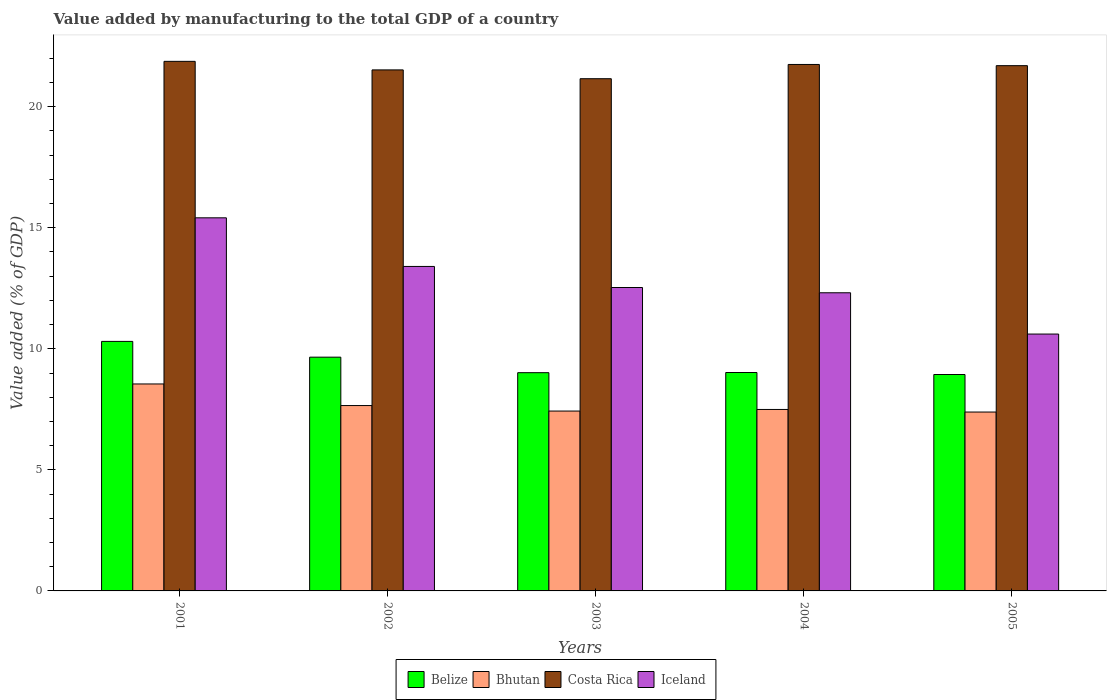How many groups of bars are there?
Make the answer very short. 5. Are the number of bars per tick equal to the number of legend labels?
Keep it short and to the point. Yes. Are the number of bars on each tick of the X-axis equal?
Your response must be concise. Yes. How many bars are there on the 1st tick from the left?
Ensure brevity in your answer.  4. How many bars are there on the 1st tick from the right?
Ensure brevity in your answer.  4. What is the label of the 3rd group of bars from the left?
Provide a short and direct response. 2003. In how many cases, is the number of bars for a given year not equal to the number of legend labels?
Provide a succinct answer. 0. What is the value added by manufacturing to the total GDP in Iceland in 2005?
Offer a terse response. 10.61. Across all years, what is the maximum value added by manufacturing to the total GDP in Bhutan?
Give a very brief answer. 8.55. Across all years, what is the minimum value added by manufacturing to the total GDP in Iceland?
Your answer should be compact. 10.61. In which year was the value added by manufacturing to the total GDP in Costa Rica minimum?
Your response must be concise. 2003. What is the total value added by manufacturing to the total GDP in Bhutan in the graph?
Make the answer very short. 38.52. What is the difference between the value added by manufacturing to the total GDP in Bhutan in 2001 and that in 2003?
Ensure brevity in your answer.  1.12. What is the difference between the value added by manufacturing to the total GDP in Bhutan in 2005 and the value added by manufacturing to the total GDP in Costa Rica in 2004?
Your response must be concise. -14.36. What is the average value added by manufacturing to the total GDP in Bhutan per year?
Offer a terse response. 7.7. In the year 2003, what is the difference between the value added by manufacturing to the total GDP in Costa Rica and value added by manufacturing to the total GDP in Belize?
Provide a short and direct response. 12.14. In how many years, is the value added by manufacturing to the total GDP in Belize greater than 10 %?
Provide a short and direct response. 1. What is the ratio of the value added by manufacturing to the total GDP in Bhutan in 2001 to that in 2005?
Provide a succinct answer. 1.16. Is the value added by manufacturing to the total GDP in Iceland in 2001 less than that in 2003?
Provide a short and direct response. No. Is the difference between the value added by manufacturing to the total GDP in Costa Rica in 2002 and 2003 greater than the difference between the value added by manufacturing to the total GDP in Belize in 2002 and 2003?
Your answer should be compact. No. What is the difference between the highest and the second highest value added by manufacturing to the total GDP in Bhutan?
Give a very brief answer. 0.89. What is the difference between the highest and the lowest value added by manufacturing to the total GDP in Belize?
Make the answer very short. 1.37. Is it the case that in every year, the sum of the value added by manufacturing to the total GDP in Costa Rica and value added by manufacturing to the total GDP in Bhutan is greater than the sum of value added by manufacturing to the total GDP in Iceland and value added by manufacturing to the total GDP in Belize?
Your response must be concise. Yes. What does the 4th bar from the left in 2001 represents?
Give a very brief answer. Iceland. What does the 4th bar from the right in 2005 represents?
Your answer should be compact. Belize. Is it the case that in every year, the sum of the value added by manufacturing to the total GDP in Costa Rica and value added by manufacturing to the total GDP in Belize is greater than the value added by manufacturing to the total GDP in Bhutan?
Your answer should be compact. Yes. How many bars are there?
Give a very brief answer. 20. Does the graph contain grids?
Your response must be concise. No. Where does the legend appear in the graph?
Keep it short and to the point. Bottom center. How are the legend labels stacked?
Give a very brief answer. Horizontal. What is the title of the graph?
Offer a very short reply. Value added by manufacturing to the total GDP of a country. What is the label or title of the X-axis?
Provide a succinct answer. Years. What is the label or title of the Y-axis?
Offer a very short reply. Value added (% of GDP). What is the Value added (% of GDP) in Belize in 2001?
Give a very brief answer. 10.31. What is the Value added (% of GDP) in Bhutan in 2001?
Your answer should be very brief. 8.55. What is the Value added (% of GDP) in Costa Rica in 2001?
Give a very brief answer. 21.87. What is the Value added (% of GDP) of Iceland in 2001?
Your answer should be very brief. 15.41. What is the Value added (% of GDP) in Belize in 2002?
Make the answer very short. 9.66. What is the Value added (% of GDP) in Bhutan in 2002?
Your answer should be very brief. 7.66. What is the Value added (% of GDP) in Costa Rica in 2002?
Ensure brevity in your answer.  21.52. What is the Value added (% of GDP) in Iceland in 2002?
Ensure brevity in your answer.  13.4. What is the Value added (% of GDP) of Belize in 2003?
Give a very brief answer. 9.01. What is the Value added (% of GDP) of Bhutan in 2003?
Give a very brief answer. 7.43. What is the Value added (% of GDP) of Costa Rica in 2003?
Give a very brief answer. 21.16. What is the Value added (% of GDP) in Iceland in 2003?
Your response must be concise. 12.53. What is the Value added (% of GDP) in Belize in 2004?
Ensure brevity in your answer.  9.02. What is the Value added (% of GDP) of Bhutan in 2004?
Offer a very short reply. 7.5. What is the Value added (% of GDP) of Costa Rica in 2004?
Your answer should be very brief. 21.74. What is the Value added (% of GDP) in Iceland in 2004?
Provide a succinct answer. 12.31. What is the Value added (% of GDP) in Belize in 2005?
Your answer should be very brief. 8.94. What is the Value added (% of GDP) in Bhutan in 2005?
Offer a very short reply. 7.39. What is the Value added (% of GDP) in Costa Rica in 2005?
Provide a short and direct response. 21.7. What is the Value added (% of GDP) in Iceland in 2005?
Ensure brevity in your answer.  10.61. Across all years, what is the maximum Value added (% of GDP) of Belize?
Your response must be concise. 10.31. Across all years, what is the maximum Value added (% of GDP) in Bhutan?
Your answer should be very brief. 8.55. Across all years, what is the maximum Value added (% of GDP) in Costa Rica?
Provide a succinct answer. 21.87. Across all years, what is the maximum Value added (% of GDP) in Iceland?
Offer a very short reply. 15.41. Across all years, what is the minimum Value added (% of GDP) in Belize?
Your answer should be compact. 8.94. Across all years, what is the minimum Value added (% of GDP) of Bhutan?
Keep it short and to the point. 7.39. Across all years, what is the minimum Value added (% of GDP) in Costa Rica?
Keep it short and to the point. 21.16. Across all years, what is the minimum Value added (% of GDP) in Iceland?
Offer a very short reply. 10.61. What is the total Value added (% of GDP) of Belize in the graph?
Offer a terse response. 46.94. What is the total Value added (% of GDP) in Bhutan in the graph?
Offer a very short reply. 38.52. What is the total Value added (% of GDP) of Costa Rica in the graph?
Your answer should be compact. 107.99. What is the total Value added (% of GDP) in Iceland in the graph?
Keep it short and to the point. 64.27. What is the difference between the Value added (% of GDP) in Belize in 2001 and that in 2002?
Offer a terse response. 0.65. What is the difference between the Value added (% of GDP) in Bhutan in 2001 and that in 2002?
Keep it short and to the point. 0.89. What is the difference between the Value added (% of GDP) of Costa Rica in 2001 and that in 2002?
Your answer should be very brief. 0.35. What is the difference between the Value added (% of GDP) in Iceland in 2001 and that in 2002?
Keep it short and to the point. 2.01. What is the difference between the Value added (% of GDP) of Belize in 2001 and that in 2003?
Your answer should be compact. 1.29. What is the difference between the Value added (% of GDP) in Bhutan in 2001 and that in 2003?
Give a very brief answer. 1.12. What is the difference between the Value added (% of GDP) of Costa Rica in 2001 and that in 2003?
Your response must be concise. 0.72. What is the difference between the Value added (% of GDP) of Iceland in 2001 and that in 2003?
Give a very brief answer. 2.88. What is the difference between the Value added (% of GDP) in Belize in 2001 and that in 2004?
Your answer should be very brief. 1.28. What is the difference between the Value added (% of GDP) in Bhutan in 2001 and that in 2004?
Offer a very short reply. 1.05. What is the difference between the Value added (% of GDP) in Costa Rica in 2001 and that in 2004?
Offer a very short reply. 0.13. What is the difference between the Value added (% of GDP) of Iceland in 2001 and that in 2004?
Your answer should be compact. 3.1. What is the difference between the Value added (% of GDP) in Belize in 2001 and that in 2005?
Your answer should be compact. 1.37. What is the difference between the Value added (% of GDP) in Bhutan in 2001 and that in 2005?
Ensure brevity in your answer.  1.16. What is the difference between the Value added (% of GDP) of Costa Rica in 2001 and that in 2005?
Your response must be concise. 0.18. What is the difference between the Value added (% of GDP) of Iceland in 2001 and that in 2005?
Your response must be concise. 4.8. What is the difference between the Value added (% of GDP) in Belize in 2002 and that in 2003?
Offer a terse response. 0.64. What is the difference between the Value added (% of GDP) of Bhutan in 2002 and that in 2003?
Provide a succinct answer. 0.23. What is the difference between the Value added (% of GDP) of Costa Rica in 2002 and that in 2003?
Your answer should be very brief. 0.36. What is the difference between the Value added (% of GDP) of Iceland in 2002 and that in 2003?
Offer a terse response. 0.87. What is the difference between the Value added (% of GDP) in Belize in 2002 and that in 2004?
Give a very brief answer. 0.63. What is the difference between the Value added (% of GDP) in Bhutan in 2002 and that in 2004?
Provide a short and direct response. 0.16. What is the difference between the Value added (% of GDP) in Costa Rica in 2002 and that in 2004?
Provide a short and direct response. -0.22. What is the difference between the Value added (% of GDP) of Iceland in 2002 and that in 2004?
Offer a terse response. 1.09. What is the difference between the Value added (% of GDP) of Belize in 2002 and that in 2005?
Ensure brevity in your answer.  0.72. What is the difference between the Value added (% of GDP) in Bhutan in 2002 and that in 2005?
Provide a short and direct response. 0.27. What is the difference between the Value added (% of GDP) of Costa Rica in 2002 and that in 2005?
Your answer should be very brief. -0.17. What is the difference between the Value added (% of GDP) in Iceland in 2002 and that in 2005?
Make the answer very short. 2.79. What is the difference between the Value added (% of GDP) of Belize in 2003 and that in 2004?
Make the answer very short. -0.01. What is the difference between the Value added (% of GDP) of Bhutan in 2003 and that in 2004?
Your answer should be very brief. -0.07. What is the difference between the Value added (% of GDP) of Costa Rica in 2003 and that in 2004?
Ensure brevity in your answer.  -0.59. What is the difference between the Value added (% of GDP) of Iceland in 2003 and that in 2004?
Your response must be concise. 0.22. What is the difference between the Value added (% of GDP) of Belize in 2003 and that in 2005?
Your response must be concise. 0.08. What is the difference between the Value added (% of GDP) in Bhutan in 2003 and that in 2005?
Offer a very short reply. 0.04. What is the difference between the Value added (% of GDP) of Costa Rica in 2003 and that in 2005?
Offer a very short reply. -0.54. What is the difference between the Value added (% of GDP) in Iceland in 2003 and that in 2005?
Your answer should be very brief. 1.92. What is the difference between the Value added (% of GDP) in Belize in 2004 and that in 2005?
Provide a short and direct response. 0.08. What is the difference between the Value added (% of GDP) in Bhutan in 2004 and that in 2005?
Ensure brevity in your answer.  0.11. What is the difference between the Value added (% of GDP) of Costa Rica in 2004 and that in 2005?
Keep it short and to the point. 0.05. What is the difference between the Value added (% of GDP) of Iceland in 2004 and that in 2005?
Ensure brevity in your answer.  1.71. What is the difference between the Value added (% of GDP) of Belize in 2001 and the Value added (% of GDP) of Bhutan in 2002?
Your answer should be compact. 2.65. What is the difference between the Value added (% of GDP) of Belize in 2001 and the Value added (% of GDP) of Costa Rica in 2002?
Your answer should be compact. -11.21. What is the difference between the Value added (% of GDP) in Belize in 2001 and the Value added (% of GDP) in Iceland in 2002?
Make the answer very short. -3.1. What is the difference between the Value added (% of GDP) in Bhutan in 2001 and the Value added (% of GDP) in Costa Rica in 2002?
Your answer should be very brief. -12.97. What is the difference between the Value added (% of GDP) of Bhutan in 2001 and the Value added (% of GDP) of Iceland in 2002?
Provide a short and direct response. -4.85. What is the difference between the Value added (% of GDP) of Costa Rica in 2001 and the Value added (% of GDP) of Iceland in 2002?
Provide a short and direct response. 8.47. What is the difference between the Value added (% of GDP) of Belize in 2001 and the Value added (% of GDP) of Bhutan in 2003?
Your response must be concise. 2.88. What is the difference between the Value added (% of GDP) in Belize in 2001 and the Value added (% of GDP) in Costa Rica in 2003?
Provide a succinct answer. -10.85. What is the difference between the Value added (% of GDP) of Belize in 2001 and the Value added (% of GDP) of Iceland in 2003?
Provide a succinct answer. -2.23. What is the difference between the Value added (% of GDP) of Bhutan in 2001 and the Value added (% of GDP) of Costa Rica in 2003?
Make the answer very short. -12.61. What is the difference between the Value added (% of GDP) in Bhutan in 2001 and the Value added (% of GDP) in Iceland in 2003?
Your answer should be very brief. -3.98. What is the difference between the Value added (% of GDP) in Costa Rica in 2001 and the Value added (% of GDP) in Iceland in 2003?
Your answer should be compact. 9.34. What is the difference between the Value added (% of GDP) of Belize in 2001 and the Value added (% of GDP) of Bhutan in 2004?
Make the answer very short. 2.81. What is the difference between the Value added (% of GDP) of Belize in 2001 and the Value added (% of GDP) of Costa Rica in 2004?
Your answer should be very brief. -11.44. What is the difference between the Value added (% of GDP) in Belize in 2001 and the Value added (% of GDP) in Iceland in 2004?
Offer a terse response. -2.01. What is the difference between the Value added (% of GDP) in Bhutan in 2001 and the Value added (% of GDP) in Costa Rica in 2004?
Provide a succinct answer. -13.2. What is the difference between the Value added (% of GDP) of Bhutan in 2001 and the Value added (% of GDP) of Iceland in 2004?
Your response must be concise. -3.77. What is the difference between the Value added (% of GDP) in Costa Rica in 2001 and the Value added (% of GDP) in Iceland in 2004?
Offer a terse response. 9.56. What is the difference between the Value added (% of GDP) of Belize in 2001 and the Value added (% of GDP) of Bhutan in 2005?
Offer a terse response. 2.92. What is the difference between the Value added (% of GDP) of Belize in 2001 and the Value added (% of GDP) of Costa Rica in 2005?
Ensure brevity in your answer.  -11.39. What is the difference between the Value added (% of GDP) of Belize in 2001 and the Value added (% of GDP) of Iceland in 2005?
Ensure brevity in your answer.  -0.3. What is the difference between the Value added (% of GDP) of Bhutan in 2001 and the Value added (% of GDP) of Costa Rica in 2005?
Provide a succinct answer. -13.15. What is the difference between the Value added (% of GDP) of Bhutan in 2001 and the Value added (% of GDP) of Iceland in 2005?
Your answer should be very brief. -2.06. What is the difference between the Value added (% of GDP) in Costa Rica in 2001 and the Value added (% of GDP) in Iceland in 2005?
Keep it short and to the point. 11.26. What is the difference between the Value added (% of GDP) of Belize in 2002 and the Value added (% of GDP) of Bhutan in 2003?
Your answer should be very brief. 2.23. What is the difference between the Value added (% of GDP) in Belize in 2002 and the Value added (% of GDP) in Costa Rica in 2003?
Provide a short and direct response. -11.5. What is the difference between the Value added (% of GDP) of Belize in 2002 and the Value added (% of GDP) of Iceland in 2003?
Offer a very short reply. -2.88. What is the difference between the Value added (% of GDP) in Bhutan in 2002 and the Value added (% of GDP) in Costa Rica in 2003?
Your response must be concise. -13.5. What is the difference between the Value added (% of GDP) in Bhutan in 2002 and the Value added (% of GDP) in Iceland in 2003?
Ensure brevity in your answer.  -4.88. What is the difference between the Value added (% of GDP) of Costa Rica in 2002 and the Value added (% of GDP) of Iceland in 2003?
Provide a succinct answer. 8.99. What is the difference between the Value added (% of GDP) in Belize in 2002 and the Value added (% of GDP) in Bhutan in 2004?
Ensure brevity in your answer.  2.16. What is the difference between the Value added (% of GDP) in Belize in 2002 and the Value added (% of GDP) in Costa Rica in 2004?
Your answer should be very brief. -12.09. What is the difference between the Value added (% of GDP) in Belize in 2002 and the Value added (% of GDP) in Iceland in 2004?
Give a very brief answer. -2.66. What is the difference between the Value added (% of GDP) of Bhutan in 2002 and the Value added (% of GDP) of Costa Rica in 2004?
Your answer should be compact. -14.09. What is the difference between the Value added (% of GDP) of Bhutan in 2002 and the Value added (% of GDP) of Iceland in 2004?
Offer a terse response. -4.66. What is the difference between the Value added (% of GDP) of Costa Rica in 2002 and the Value added (% of GDP) of Iceland in 2004?
Ensure brevity in your answer.  9.21. What is the difference between the Value added (% of GDP) of Belize in 2002 and the Value added (% of GDP) of Bhutan in 2005?
Provide a succinct answer. 2.27. What is the difference between the Value added (% of GDP) of Belize in 2002 and the Value added (% of GDP) of Costa Rica in 2005?
Keep it short and to the point. -12.04. What is the difference between the Value added (% of GDP) in Belize in 2002 and the Value added (% of GDP) in Iceland in 2005?
Give a very brief answer. -0.95. What is the difference between the Value added (% of GDP) of Bhutan in 2002 and the Value added (% of GDP) of Costa Rica in 2005?
Offer a very short reply. -14.04. What is the difference between the Value added (% of GDP) in Bhutan in 2002 and the Value added (% of GDP) in Iceland in 2005?
Provide a short and direct response. -2.95. What is the difference between the Value added (% of GDP) of Costa Rica in 2002 and the Value added (% of GDP) of Iceland in 2005?
Your answer should be very brief. 10.91. What is the difference between the Value added (% of GDP) in Belize in 2003 and the Value added (% of GDP) in Bhutan in 2004?
Your answer should be very brief. 1.52. What is the difference between the Value added (% of GDP) of Belize in 2003 and the Value added (% of GDP) of Costa Rica in 2004?
Your response must be concise. -12.73. What is the difference between the Value added (% of GDP) of Belize in 2003 and the Value added (% of GDP) of Iceland in 2004?
Make the answer very short. -3.3. What is the difference between the Value added (% of GDP) of Bhutan in 2003 and the Value added (% of GDP) of Costa Rica in 2004?
Offer a very short reply. -14.32. What is the difference between the Value added (% of GDP) in Bhutan in 2003 and the Value added (% of GDP) in Iceland in 2004?
Make the answer very short. -4.89. What is the difference between the Value added (% of GDP) of Costa Rica in 2003 and the Value added (% of GDP) of Iceland in 2004?
Give a very brief answer. 8.84. What is the difference between the Value added (% of GDP) of Belize in 2003 and the Value added (% of GDP) of Bhutan in 2005?
Ensure brevity in your answer.  1.63. What is the difference between the Value added (% of GDP) in Belize in 2003 and the Value added (% of GDP) in Costa Rica in 2005?
Your answer should be compact. -12.68. What is the difference between the Value added (% of GDP) in Belize in 2003 and the Value added (% of GDP) in Iceland in 2005?
Provide a succinct answer. -1.6. What is the difference between the Value added (% of GDP) in Bhutan in 2003 and the Value added (% of GDP) in Costa Rica in 2005?
Offer a terse response. -14.27. What is the difference between the Value added (% of GDP) of Bhutan in 2003 and the Value added (% of GDP) of Iceland in 2005?
Offer a terse response. -3.18. What is the difference between the Value added (% of GDP) of Costa Rica in 2003 and the Value added (% of GDP) of Iceland in 2005?
Ensure brevity in your answer.  10.55. What is the difference between the Value added (% of GDP) of Belize in 2004 and the Value added (% of GDP) of Bhutan in 2005?
Give a very brief answer. 1.63. What is the difference between the Value added (% of GDP) of Belize in 2004 and the Value added (% of GDP) of Costa Rica in 2005?
Make the answer very short. -12.67. What is the difference between the Value added (% of GDP) in Belize in 2004 and the Value added (% of GDP) in Iceland in 2005?
Give a very brief answer. -1.59. What is the difference between the Value added (% of GDP) of Bhutan in 2004 and the Value added (% of GDP) of Costa Rica in 2005?
Give a very brief answer. -14.2. What is the difference between the Value added (% of GDP) in Bhutan in 2004 and the Value added (% of GDP) in Iceland in 2005?
Make the answer very short. -3.11. What is the difference between the Value added (% of GDP) in Costa Rica in 2004 and the Value added (% of GDP) in Iceland in 2005?
Your answer should be very brief. 11.14. What is the average Value added (% of GDP) of Belize per year?
Your answer should be compact. 9.39. What is the average Value added (% of GDP) of Bhutan per year?
Provide a succinct answer. 7.7. What is the average Value added (% of GDP) in Costa Rica per year?
Your response must be concise. 21.6. What is the average Value added (% of GDP) of Iceland per year?
Give a very brief answer. 12.85. In the year 2001, what is the difference between the Value added (% of GDP) in Belize and Value added (% of GDP) in Bhutan?
Your response must be concise. 1.76. In the year 2001, what is the difference between the Value added (% of GDP) of Belize and Value added (% of GDP) of Costa Rica?
Make the answer very short. -11.57. In the year 2001, what is the difference between the Value added (% of GDP) of Belize and Value added (% of GDP) of Iceland?
Give a very brief answer. -5.1. In the year 2001, what is the difference between the Value added (% of GDP) in Bhutan and Value added (% of GDP) in Costa Rica?
Keep it short and to the point. -13.33. In the year 2001, what is the difference between the Value added (% of GDP) of Bhutan and Value added (% of GDP) of Iceland?
Offer a very short reply. -6.86. In the year 2001, what is the difference between the Value added (% of GDP) in Costa Rica and Value added (% of GDP) in Iceland?
Make the answer very short. 6.46. In the year 2002, what is the difference between the Value added (% of GDP) of Belize and Value added (% of GDP) of Bhutan?
Provide a short and direct response. 2. In the year 2002, what is the difference between the Value added (% of GDP) of Belize and Value added (% of GDP) of Costa Rica?
Give a very brief answer. -11.87. In the year 2002, what is the difference between the Value added (% of GDP) of Belize and Value added (% of GDP) of Iceland?
Provide a short and direct response. -3.75. In the year 2002, what is the difference between the Value added (% of GDP) in Bhutan and Value added (% of GDP) in Costa Rica?
Offer a terse response. -13.86. In the year 2002, what is the difference between the Value added (% of GDP) of Bhutan and Value added (% of GDP) of Iceland?
Your response must be concise. -5.75. In the year 2002, what is the difference between the Value added (% of GDP) in Costa Rica and Value added (% of GDP) in Iceland?
Your response must be concise. 8.12. In the year 2003, what is the difference between the Value added (% of GDP) in Belize and Value added (% of GDP) in Bhutan?
Ensure brevity in your answer.  1.58. In the year 2003, what is the difference between the Value added (% of GDP) in Belize and Value added (% of GDP) in Costa Rica?
Your answer should be very brief. -12.14. In the year 2003, what is the difference between the Value added (% of GDP) in Belize and Value added (% of GDP) in Iceland?
Make the answer very short. -3.52. In the year 2003, what is the difference between the Value added (% of GDP) in Bhutan and Value added (% of GDP) in Costa Rica?
Make the answer very short. -13.73. In the year 2003, what is the difference between the Value added (% of GDP) of Bhutan and Value added (% of GDP) of Iceland?
Keep it short and to the point. -5.1. In the year 2003, what is the difference between the Value added (% of GDP) in Costa Rica and Value added (% of GDP) in Iceland?
Your answer should be very brief. 8.62. In the year 2004, what is the difference between the Value added (% of GDP) in Belize and Value added (% of GDP) in Bhutan?
Offer a terse response. 1.53. In the year 2004, what is the difference between the Value added (% of GDP) in Belize and Value added (% of GDP) in Costa Rica?
Provide a succinct answer. -12.72. In the year 2004, what is the difference between the Value added (% of GDP) of Belize and Value added (% of GDP) of Iceland?
Offer a very short reply. -3.29. In the year 2004, what is the difference between the Value added (% of GDP) in Bhutan and Value added (% of GDP) in Costa Rica?
Your answer should be very brief. -14.25. In the year 2004, what is the difference between the Value added (% of GDP) in Bhutan and Value added (% of GDP) in Iceland?
Offer a terse response. -4.82. In the year 2004, what is the difference between the Value added (% of GDP) of Costa Rica and Value added (% of GDP) of Iceland?
Provide a succinct answer. 9.43. In the year 2005, what is the difference between the Value added (% of GDP) of Belize and Value added (% of GDP) of Bhutan?
Provide a succinct answer. 1.55. In the year 2005, what is the difference between the Value added (% of GDP) of Belize and Value added (% of GDP) of Costa Rica?
Give a very brief answer. -12.76. In the year 2005, what is the difference between the Value added (% of GDP) in Belize and Value added (% of GDP) in Iceland?
Give a very brief answer. -1.67. In the year 2005, what is the difference between the Value added (% of GDP) of Bhutan and Value added (% of GDP) of Costa Rica?
Ensure brevity in your answer.  -14.31. In the year 2005, what is the difference between the Value added (% of GDP) in Bhutan and Value added (% of GDP) in Iceland?
Ensure brevity in your answer.  -3.22. In the year 2005, what is the difference between the Value added (% of GDP) of Costa Rica and Value added (% of GDP) of Iceland?
Your answer should be compact. 11.09. What is the ratio of the Value added (% of GDP) in Belize in 2001 to that in 2002?
Offer a terse response. 1.07. What is the ratio of the Value added (% of GDP) of Bhutan in 2001 to that in 2002?
Your response must be concise. 1.12. What is the ratio of the Value added (% of GDP) in Costa Rica in 2001 to that in 2002?
Give a very brief answer. 1.02. What is the ratio of the Value added (% of GDP) in Iceland in 2001 to that in 2002?
Offer a terse response. 1.15. What is the ratio of the Value added (% of GDP) of Belize in 2001 to that in 2003?
Provide a short and direct response. 1.14. What is the ratio of the Value added (% of GDP) of Bhutan in 2001 to that in 2003?
Ensure brevity in your answer.  1.15. What is the ratio of the Value added (% of GDP) of Costa Rica in 2001 to that in 2003?
Make the answer very short. 1.03. What is the ratio of the Value added (% of GDP) in Iceland in 2001 to that in 2003?
Your answer should be compact. 1.23. What is the ratio of the Value added (% of GDP) of Belize in 2001 to that in 2004?
Your response must be concise. 1.14. What is the ratio of the Value added (% of GDP) in Bhutan in 2001 to that in 2004?
Your answer should be compact. 1.14. What is the ratio of the Value added (% of GDP) in Costa Rica in 2001 to that in 2004?
Provide a succinct answer. 1.01. What is the ratio of the Value added (% of GDP) in Iceland in 2001 to that in 2004?
Your response must be concise. 1.25. What is the ratio of the Value added (% of GDP) in Belize in 2001 to that in 2005?
Offer a very short reply. 1.15. What is the ratio of the Value added (% of GDP) in Bhutan in 2001 to that in 2005?
Provide a short and direct response. 1.16. What is the ratio of the Value added (% of GDP) of Costa Rica in 2001 to that in 2005?
Your answer should be compact. 1.01. What is the ratio of the Value added (% of GDP) in Iceland in 2001 to that in 2005?
Offer a terse response. 1.45. What is the ratio of the Value added (% of GDP) of Belize in 2002 to that in 2003?
Provide a short and direct response. 1.07. What is the ratio of the Value added (% of GDP) in Bhutan in 2002 to that in 2003?
Offer a terse response. 1.03. What is the ratio of the Value added (% of GDP) of Costa Rica in 2002 to that in 2003?
Your answer should be compact. 1.02. What is the ratio of the Value added (% of GDP) in Iceland in 2002 to that in 2003?
Keep it short and to the point. 1.07. What is the ratio of the Value added (% of GDP) of Belize in 2002 to that in 2004?
Ensure brevity in your answer.  1.07. What is the ratio of the Value added (% of GDP) in Bhutan in 2002 to that in 2004?
Provide a succinct answer. 1.02. What is the ratio of the Value added (% of GDP) of Iceland in 2002 to that in 2004?
Ensure brevity in your answer.  1.09. What is the ratio of the Value added (% of GDP) of Belize in 2002 to that in 2005?
Your response must be concise. 1.08. What is the ratio of the Value added (% of GDP) of Bhutan in 2002 to that in 2005?
Ensure brevity in your answer.  1.04. What is the ratio of the Value added (% of GDP) in Iceland in 2002 to that in 2005?
Provide a succinct answer. 1.26. What is the ratio of the Value added (% of GDP) of Costa Rica in 2003 to that in 2004?
Keep it short and to the point. 0.97. What is the ratio of the Value added (% of GDP) of Iceland in 2003 to that in 2004?
Provide a short and direct response. 1.02. What is the ratio of the Value added (% of GDP) of Belize in 2003 to that in 2005?
Give a very brief answer. 1.01. What is the ratio of the Value added (% of GDP) of Costa Rica in 2003 to that in 2005?
Provide a succinct answer. 0.98. What is the ratio of the Value added (% of GDP) of Iceland in 2003 to that in 2005?
Provide a succinct answer. 1.18. What is the ratio of the Value added (% of GDP) of Belize in 2004 to that in 2005?
Offer a terse response. 1.01. What is the ratio of the Value added (% of GDP) of Bhutan in 2004 to that in 2005?
Provide a short and direct response. 1.01. What is the ratio of the Value added (% of GDP) of Costa Rica in 2004 to that in 2005?
Provide a succinct answer. 1. What is the ratio of the Value added (% of GDP) in Iceland in 2004 to that in 2005?
Ensure brevity in your answer.  1.16. What is the difference between the highest and the second highest Value added (% of GDP) in Belize?
Your answer should be compact. 0.65. What is the difference between the highest and the second highest Value added (% of GDP) of Bhutan?
Keep it short and to the point. 0.89. What is the difference between the highest and the second highest Value added (% of GDP) in Costa Rica?
Make the answer very short. 0.13. What is the difference between the highest and the second highest Value added (% of GDP) of Iceland?
Ensure brevity in your answer.  2.01. What is the difference between the highest and the lowest Value added (% of GDP) in Belize?
Keep it short and to the point. 1.37. What is the difference between the highest and the lowest Value added (% of GDP) of Bhutan?
Offer a very short reply. 1.16. What is the difference between the highest and the lowest Value added (% of GDP) of Costa Rica?
Your response must be concise. 0.72. What is the difference between the highest and the lowest Value added (% of GDP) in Iceland?
Make the answer very short. 4.8. 